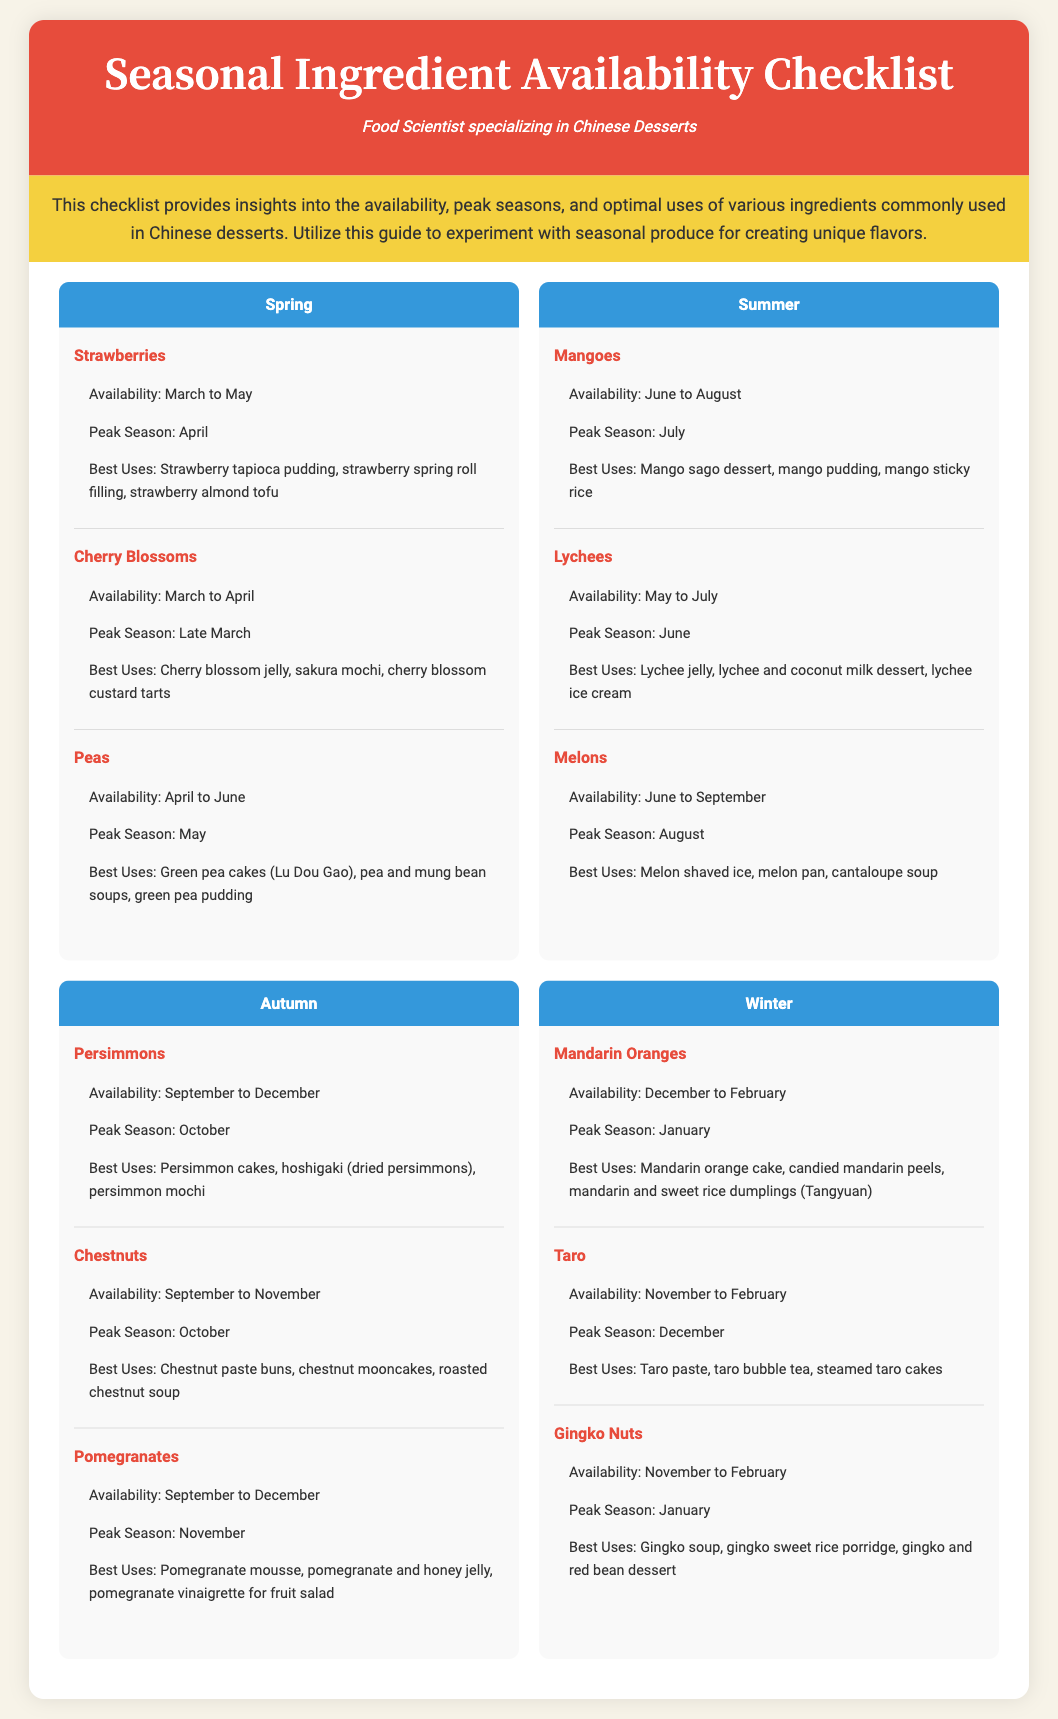what is the peak season for strawberries? The peak season for strawberries is mentioned in the document under Spring, which states it is April.
Answer: April what is the availability period for lychees? The document provides the availability period for lychees, which is from May to July.
Answer: May to July which ingredient is best used for making green pea cakes? The document lists various ingredients and their best uses, specifying that peas are best used for making green pea cakes (Lu Dou Gao).
Answer: Peas how many ingredients are listed under the Autumn season? The document outlines the number of ingredients in the Autumn section, which lists three: Persimmons, Chestnuts, and Pomegranates.
Answer: 3 what dessert can be made with chestnuts? The document indicates that one of the best uses for chestnuts is in chestnut mooncakes.
Answer: Chestnut mooncakes what is the availability for mandarins? The availability period for mandarins is given in the Winter section, indicating they are available from December to February.
Answer: December to February which ingredient has a peak season in November? The document states that the peak season for pomegranates occurs in November.
Answer: Pomegranates when is the peak season for mangoes? The document states that the peak season for mangoes is July.
Answer: July which season includes the ingredient 'taro'? The document categorizes taro under the Winter season.
Answer: Winter 